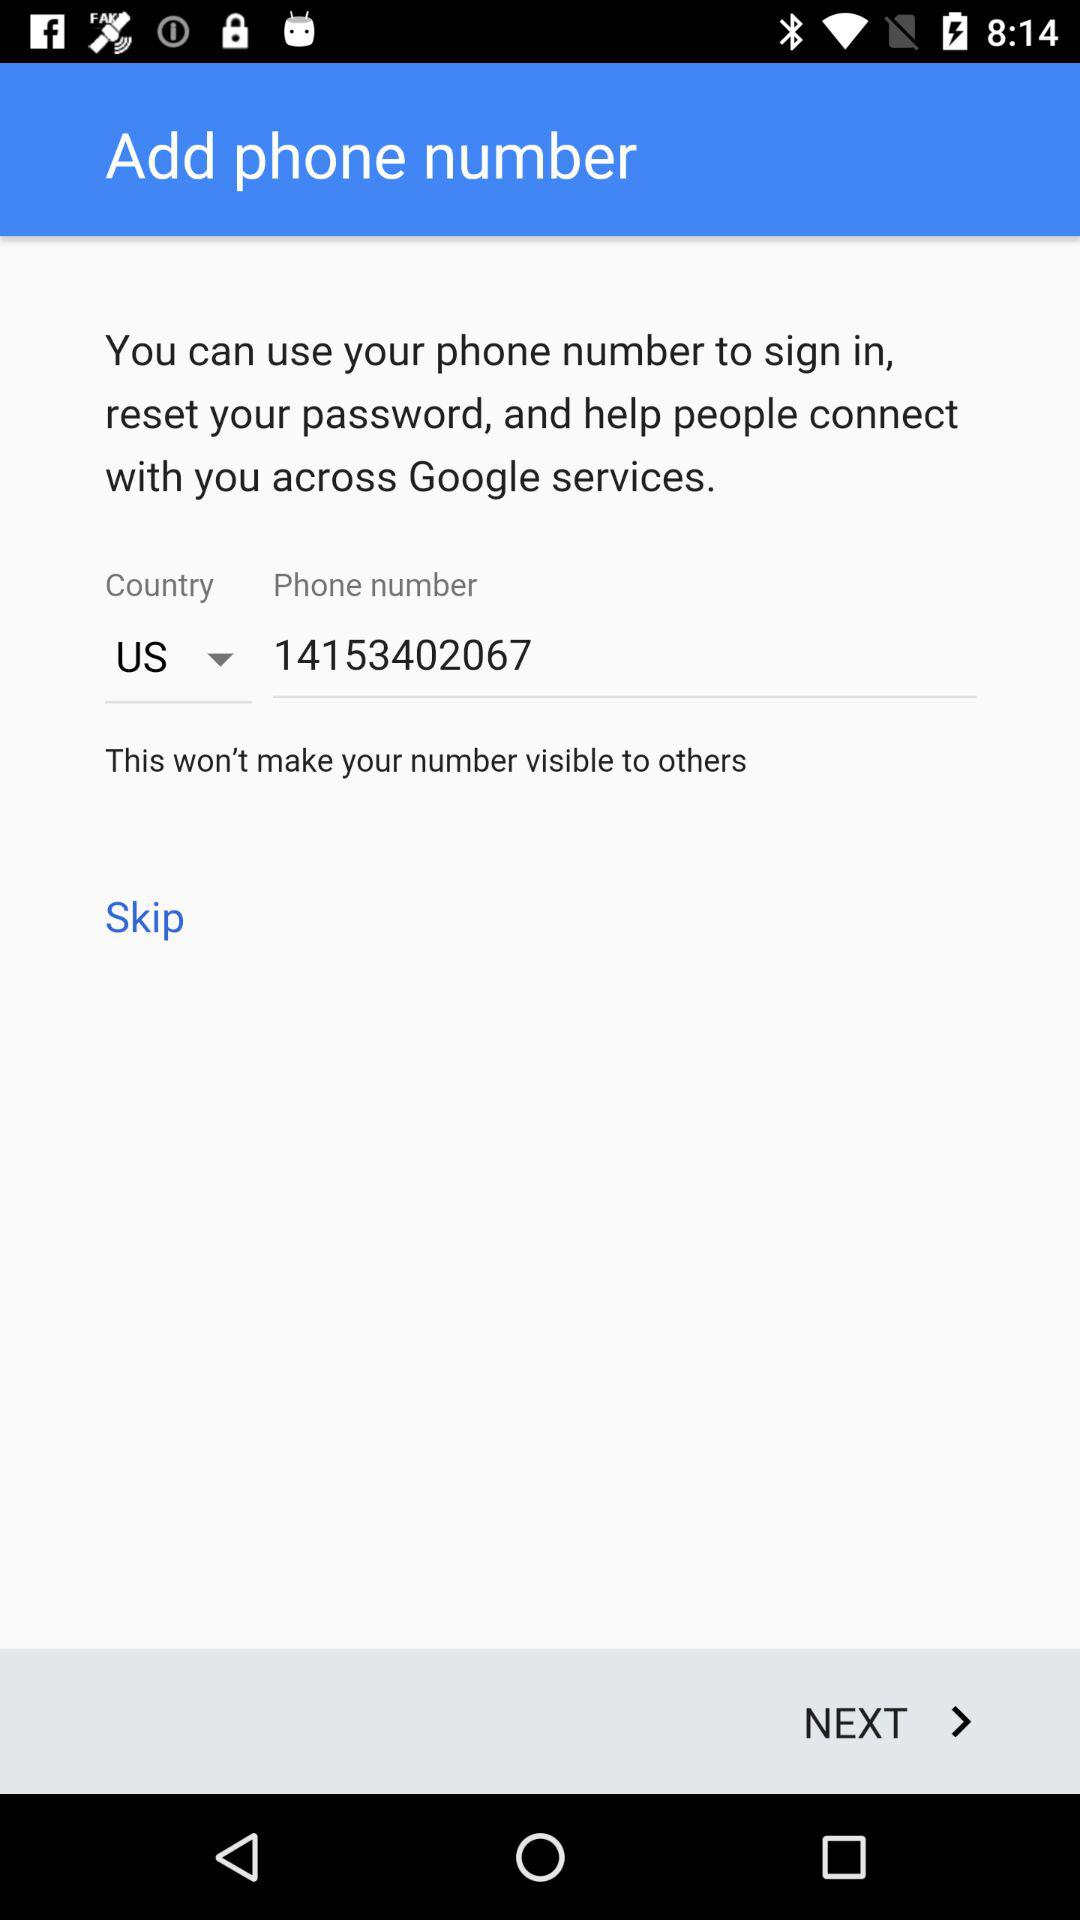What is the phone number? The phone number is 14153402067. 